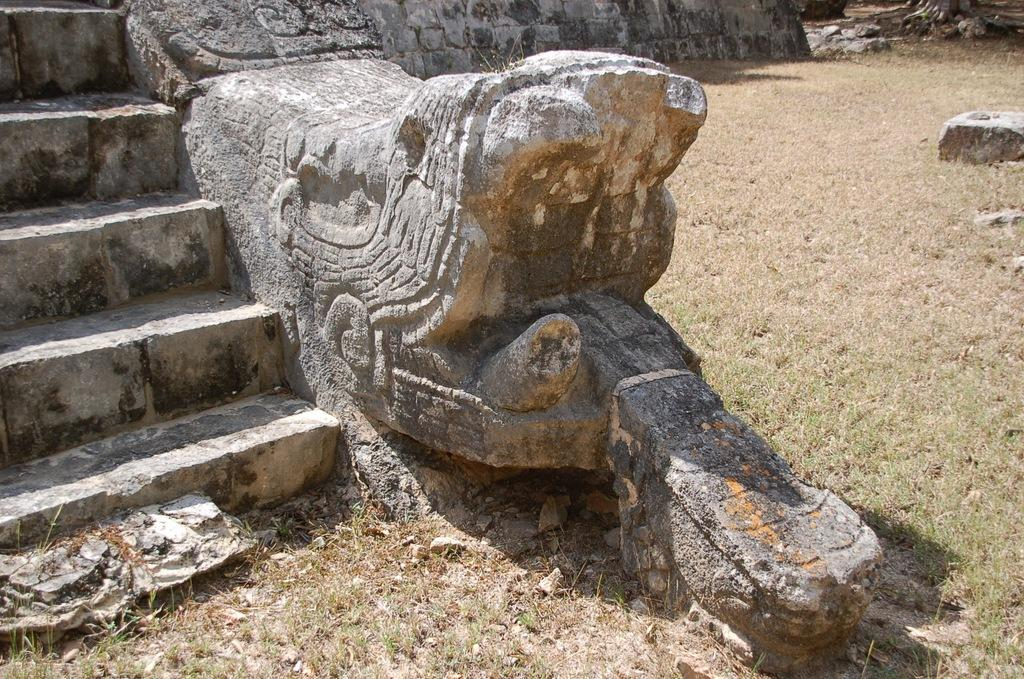What type of architectural feature can be seen in the image? There are steps in the image. What is located on the ground in the image? There is a rock chiseled in a shape in the image. Where is the rock situated in relation to the ground? The rock is on the ground. What is visible at the bottom of the image? The ground is visible at the bottom of the image. What type of music can be heard playing in the background of the image? There is no music present in the image, as it is a still photograph. Can you see a sofa in the image? There is no sofa present in the image; it features steps and a rock on the ground. 